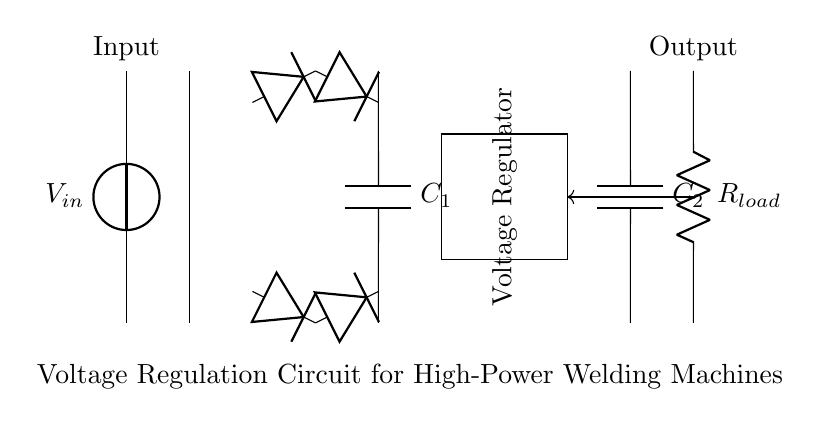What is the main purpose of the circuit? The main purpose of the circuit is to regulate the voltage for high-power welding machines, ensuring stable and consistent performance during operation.
Answer: Voltage regulation What component is used for smoothing the output voltage? The component used for smoothing the output voltage is a capacitor, which charges and discharges to reduce voltage fluctuations.
Answer: Capacitor How many diodes are in the rectifier bridge? There are four diodes in the rectifier bridge; they are arranged in a bridge configuration to convert AC input to DC output.
Answer: Four What does the feedback loop in the circuit indicate? The feedback loop indicates that the circuit monitors the output voltage and adjusts the regulation to maintain a stable output level, which is crucial for the performance of high-power appliances.
Answer: Output regulation What type of load is connected at the output? The load connected at the output is a resistor, which represents the welding machine and its impedance, directly affecting the circuit's operation.
Answer: Resistor What is the role of the voltage regulator? The voltage regulator's role is to ensure that the output voltage remains at a specified level despite variations in the input voltage or load conditions.
Answer: Stabilization 